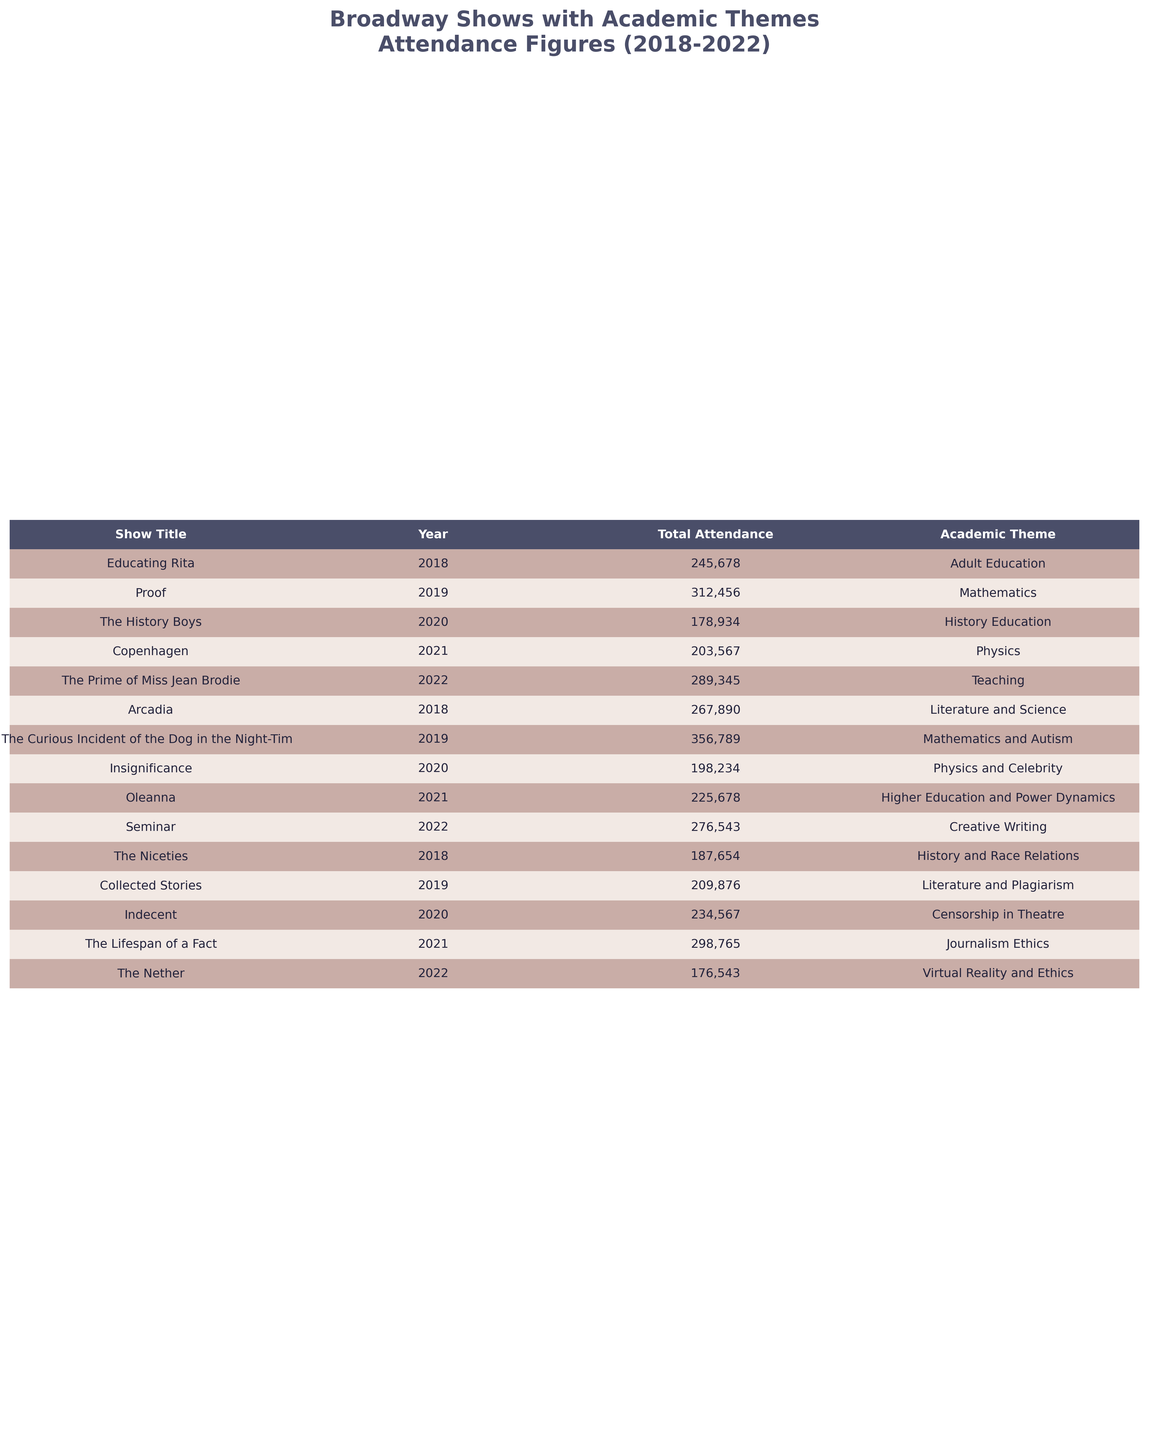What was the total attendance for "Proof" in 2019? The table shows that "Proof" had a total attendance of 312,456 in the year 2019.
Answer: 312,456 Which show had the highest attendance between 2018 and 2022? Looking through the attendance figures, "The Curious Incident of the Dog in the Night-Time" in 2019 had the highest attendance at 356,789.
Answer: 356,789 What was the average attendance for shows focusing on Mathematics from 2018 to 2022? The shows on Mathematics are "Proof" (312,456) and "The Curious Incident of the Dog in the Night-Time" (356,789). The total attendance is 312,456 + 356,789 = 669,245. There are 2 shows, so the average attendance is 669,245 / 2 = 334,622.5, rounded down gives 334,622.
Answer: 334,622 Did any show with the theme of "History" have a total attendance of more than 200,000? The show "The History Boys" had an attendance of 178,934, and no other history-themed shows were listed, so all are below 200,000.
Answer: No What was the difference in attendance between "Educating Rita" in 2018 and "The Lifespan of a Fact" in 2021? "Educating Rita" had an attendance of 245,678, while "The Lifespan of a Fact" had 298,765. The difference is 298,765 - 245,678 = 53,087.
Answer: 53,087 Which year had the least total attendance across all shows? By assessing the total attendance figures: 2018 = 245,678 + 267,890 + 187,654 = 701,222; 2019 = 312,456 + 356,789 + 209,876 = 879,121; 2020 = 178,934 + 198,234 + 234,567 = 611,735; 2021 = 203,567 + 225,678 + 298,765 = 727,010; 2022 = 289,345 + 276,543 + 176,543 = 742,431. The year with the least total attendance is 2020 with 611,735.
Answer: 2020 How many shows had a theme related to the field of Physics? The shows with a theme of Physics are "Copenhagen", "Insignificance", and "The Lifespan of a Fact", totaling 3 shows.
Answer: 3 